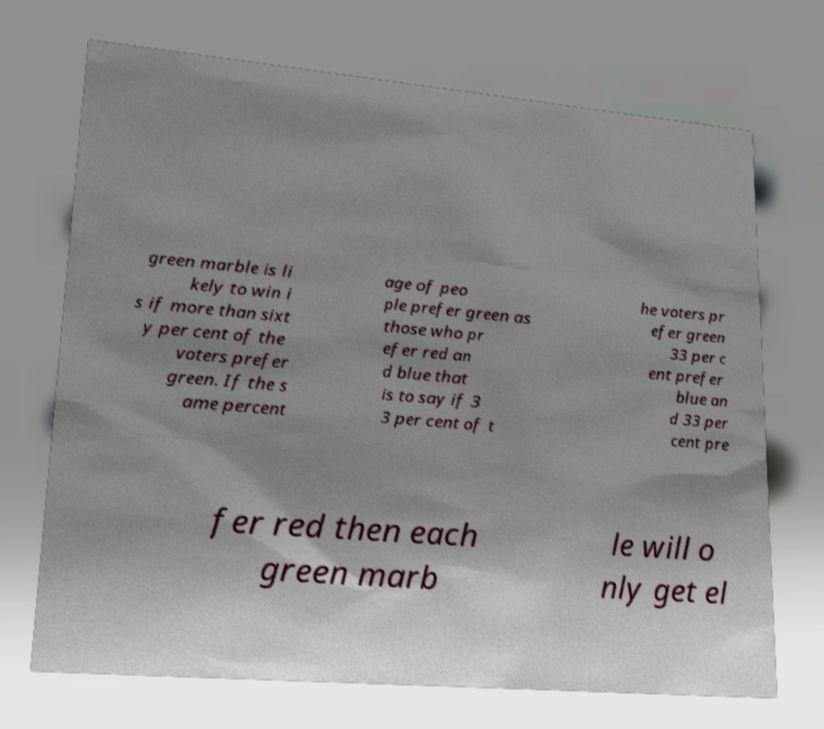What messages or text are displayed in this image? I need them in a readable, typed format. green marble is li kely to win i s if more than sixt y per cent of the voters prefer green. If the s ame percent age of peo ple prefer green as those who pr efer red an d blue that is to say if 3 3 per cent of t he voters pr efer green 33 per c ent prefer blue an d 33 per cent pre fer red then each green marb le will o nly get el 